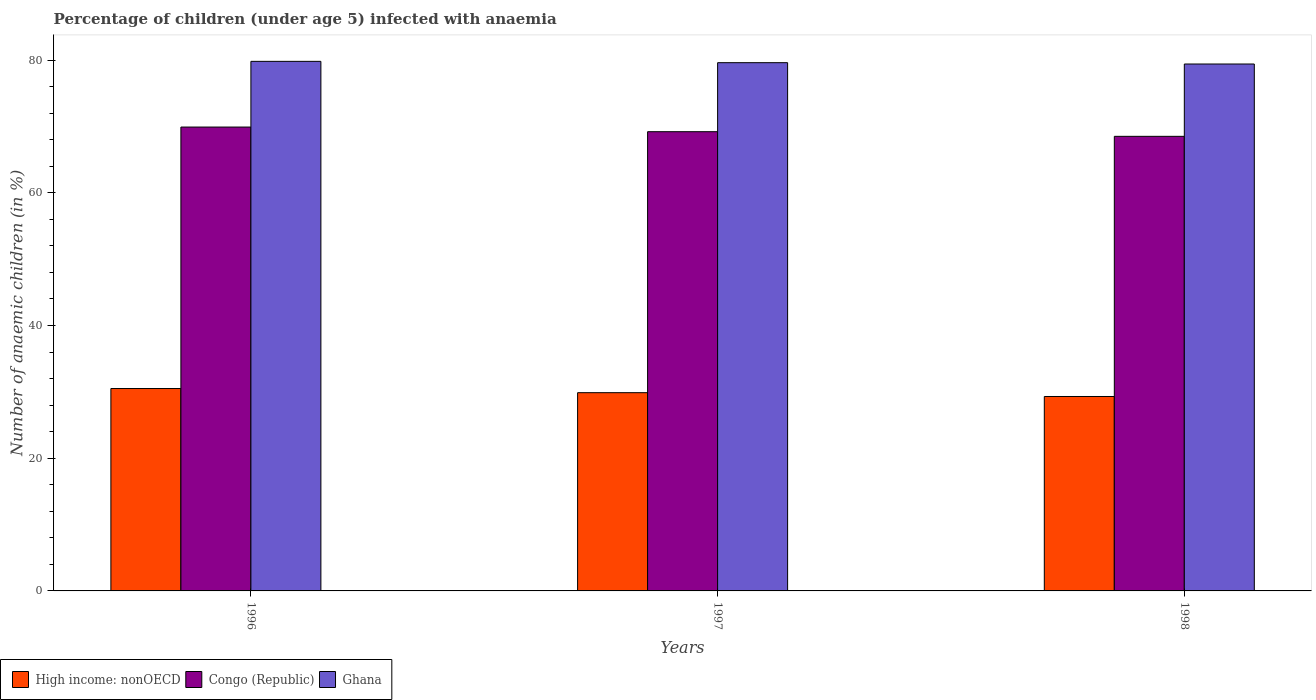How many groups of bars are there?
Offer a very short reply. 3. Are the number of bars on each tick of the X-axis equal?
Give a very brief answer. Yes. How many bars are there on the 2nd tick from the right?
Provide a short and direct response. 3. In how many cases, is the number of bars for a given year not equal to the number of legend labels?
Your response must be concise. 0. What is the percentage of children infected with anaemia in in Ghana in 1998?
Ensure brevity in your answer.  79.4. Across all years, what is the maximum percentage of children infected with anaemia in in Congo (Republic)?
Keep it short and to the point. 69.9. Across all years, what is the minimum percentage of children infected with anaemia in in High income: nonOECD?
Offer a very short reply. 29.3. In which year was the percentage of children infected with anaemia in in Congo (Republic) maximum?
Offer a very short reply. 1996. What is the total percentage of children infected with anaemia in in Ghana in the graph?
Keep it short and to the point. 238.8. What is the difference between the percentage of children infected with anaemia in in Ghana in 1996 and that in 1997?
Your answer should be compact. 0.2. What is the difference between the percentage of children infected with anaemia in in Congo (Republic) in 1997 and the percentage of children infected with anaemia in in High income: nonOECD in 1996?
Your answer should be compact. 38.7. What is the average percentage of children infected with anaemia in in High income: nonOECD per year?
Offer a very short reply. 29.89. In the year 1998, what is the difference between the percentage of children infected with anaemia in in Ghana and percentage of children infected with anaemia in in Congo (Republic)?
Give a very brief answer. 10.9. What is the ratio of the percentage of children infected with anaemia in in Ghana in 1996 to that in 1998?
Provide a succinct answer. 1.01. What is the difference between the highest and the second highest percentage of children infected with anaemia in in Ghana?
Give a very brief answer. 0.2. What is the difference between the highest and the lowest percentage of children infected with anaemia in in Ghana?
Give a very brief answer. 0.4. Is the sum of the percentage of children infected with anaemia in in Congo (Republic) in 1996 and 1998 greater than the maximum percentage of children infected with anaemia in in High income: nonOECD across all years?
Make the answer very short. Yes. What does the 3rd bar from the right in 1996 represents?
Offer a terse response. High income: nonOECD. How many bars are there?
Your answer should be very brief. 9. Are all the bars in the graph horizontal?
Your answer should be very brief. No. How many years are there in the graph?
Your answer should be very brief. 3. What is the difference between two consecutive major ticks on the Y-axis?
Provide a short and direct response. 20. Are the values on the major ticks of Y-axis written in scientific E-notation?
Offer a terse response. No. Does the graph contain grids?
Provide a succinct answer. No. Where does the legend appear in the graph?
Ensure brevity in your answer.  Bottom left. How many legend labels are there?
Your answer should be compact. 3. How are the legend labels stacked?
Your answer should be very brief. Horizontal. What is the title of the graph?
Provide a short and direct response. Percentage of children (under age 5) infected with anaemia. Does "Upper middle income" appear as one of the legend labels in the graph?
Keep it short and to the point. No. What is the label or title of the Y-axis?
Provide a succinct answer. Number of anaemic children (in %). What is the Number of anaemic children (in %) of High income: nonOECD in 1996?
Offer a very short reply. 30.5. What is the Number of anaemic children (in %) in Congo (Republic) in 1996?
Ensure brevity in your answer.  69.9. What is the Number of anaemic children (in %) of Ghana in 1996?
Offer a terse response. 79.8. What is the Number of anaemic children (in %) in High income: nonOECD in 1997?
Your answer should be compact. 29.87. What is the Number of anaemic children (in %) in Congo (Republic) in 1997?
Provide a succinct answer. 69.2. What is the Number of anaemic children (in %) in Ghana in 1997?
Provide a succinct answer. 79.6. What is the Number of anaemic children (in %) of High income: nonOECD in 1998?
Offer a terse response. 29.3. What is the Number of anaemic children (in %) in Congo (Republic) in 1998?
Make the answer very short. 68.5. What is the Number of anaemic children (in %) in Ghana in 1998?
Make the answer very short. 79.4. Across all years, what is the maximum Number of anaemic children (in %) of High income: nonOECD?
Make the answer very short. 30.5. Across all years, what is the maximum Number of anaemic children (in %) of Congo (Republic)?
Offer a very short reply. 69.9. Across all years, what is the maximum Number of anaemic children (in %) in Ghana?
Your answer should be compact. 79.8. Across all years, what is the minimum Number of anaemic children (in %) in High income: nonOECD?
Your answer should be compact. 29.3. Across all years, what is the minimum Number of anaemic children (in %) of Congo (Republic)?
Provide a short and direct response. 68.5. Across all years, what is the minimum Number of anaemic children (in %) in Ghana?
Offer a terse response. 79.4. What is the total Number of anaemic children (in %) in High income: nonOECD in the graph?
Keep it short and to the point. 89.67. What is the total Number of anaemic children (in %) in Congo (Republic) in the graph?
Offer a very short reply. 207.6. What is the total Number of anaemic children (in %) in Ghana in the graph?
Provide a succinct answer. 238.8. What is the difference between the Number of anaemic children (in %) of High income: nonOECD in 1996 and that in 1997?
Provide a short and direct response. 0.63. What is the difference between the Number of anaemic children (in %) of Congo (Republic) in 1996 and that in 1997?
Provide a short and direct response. 0.7. What is the difference between the Number of anaemic children (in %) of Ghana in 1996 and that in 1997?
Your answer should be very brief. 0.2. What is the difference between the Number of anaemic children (in %) of High income: nonOECD in 1996 and that in 1998?
Keep it short and to the point. 1.2. What is the difference between the Number of anaemic children (in %) in Congo (Republic) in 1996 and that in 1998?
Offer a very short reply. 1.4. What is the difference between the Number of anaemic children (in %) in Ghana in 1996 and that in 1998?
Offer a terse response. 0.4. What is the difference between the Number of anaemic children (in %) in High income: nonOECD in 1997 and that in 1998?
Provide a succinct answer. 0.57. What is the difference between the Number of anaemic children (in %) in Congo (Republic) in 1997 and that in 1998?
Your response must be concise. 0.7. What is the difference between the Number of anaemic children (in %) of Ghana in 1997 and that in 1998?
Provide a succinct answer. 0.2. What is the difference between the Number of anaemic children (in %) of High income: nonOECD in 1996 and the Number of anaemic children (in %) of Congo (Republic) in 1997?
Your answer should be compact. -38.7. What is the difference between the Number of anaemic children (in %) in High income: nonOECD in 1996 and the Number of anaemic children (in %) in Ghana in 1997?
Give a very brief answer. -49.1. What is the difference between the Number of anaemic children (in %) in Congo (Republic) in 1996 and the Number of anaemic children (in %) in Ghana in 1997?
Your response must be concise. -9.7. What is the difference between the Number of anaemic children (in %) in High income: nonOECD in 1996 and the Number of anaemic children (in %) in Congo (Republic) in 1998?
Offer a terse response. -38. What is the difference between the Number of anaemic children (in %) of High income: nonOECD in 1996 and the Number of anaemic children (in %) of Ghana in 1998?
Make the answer very short. -48.9. What is the difference between the Number of anaemic children (in %) in Congo (Republic) in 1996 and the Number of anaemic children (in %) in Ghana in 1998?
Your response must be concise. -9.5. What is the difference between the Number of anaemic children (in %) in High income: nonOECD in 1997 and the Number of anaemic children (in %) in Congo (Republic) in 1998?
Your answer should be very brief. -38.63. What is the difference between the Number of anaemic children (in %) of High income: nonOECD in 1997 and the Number of anaemic children (in %) of Ghana in 1998?
Provide a short and direct response. -49.53. What is the difference between the Number of anaemic children (in %) of Congo (Republic) in 1997 and the Number of anaemic children (in %) of Ghana in 1998?
Make the answer very short. -10.2. What is the average Number of anaemic children (in %) in High income: nonOECD per year?
Your answer should be very brief. 29.89. What is the average Number of anaemic children (in %) of Congo (Republic) per year?
Make the answer very short. 69.2. What is the average Number of anaemic children (in %) in Ghana per year?
Offer a very short reply. 79.6. In the year 1996, what is the difference between the Number of anaemic children (in %) in High income: nonOECD and Number of anaemic children (in %) in Congo (Republic)?
Your answer should be very brief. -39.4. In the year 1996, what is the difference between the Number of anaemic children (in %) of High income: nonOECD and Number of anaemic children (in %) of Ghana?
Give a very brief answer. -49.3. In the year 1997, what is the difference between the Number of anaemic children (in %) of High income: nonOECD and Number of anaemic children (in %) of Congo (Republic)?
Make the answer very short. -39.33. In the year 1997, what is the difference between the Number of anaemic children (in %) of High income: nonOECD and Number of anaemic children (in %) of Ghana?
Offer a very short reply. -49.73. In the year 1997, what is the difference between the Number of anaemic children (in %) of Congo (Republic) and Number of anaemic children (in %) of Ghana?
Provide a succinct answer. -10.4. In the year 1998, what is the difference between the Number of anaemic children (in %) in High income: nonOECD and Number of anaemic children (in %) in Congo (Republic)?
Ensure brevity in your answer.  -39.2. In the year 1998, what is the difference between the Number of anaemic children (in %) in High income: nonOECD and Number of anaemic children (in %) in Ghana?
Ensure brevity in your answer.  -50.1. In the year 1998, what is the difference between the Number of anaemic children (in %) in Congo (Republic) and Number of anaemic children (in %) in Ghana?
Offer a very short reply. -10.9. What is the ratio of the Number of anaemic children (in %) in High income: nonOECD in 1996 to that in 1997?
Ensure brevity in your answer.  1.02. What is the ratio of the Number of anaemic children (in %) in High income: nonOECD in 1996 to that in 1998?
Make the answer very short. 1.04. What is the ratio of the Number of anaemic children (in %) in Congo (Republic) in 1996 to that in 1998?
Ensure brevity in your answer.  1.02. What is the ratio of the Number of anaemic children (in %) of High income: nonOECD in 1997 to that in 1998?
Offer a very short reply. 1.02. What is the ratio of the Number of anaemic children (in %) in Congo (Republic) in 1997 to that in 1998?
Your response must be concise. 1.01. What is the ratio of the Number of anaemic children (in %) of Ghana in 1997 to that in 1998?
Your answer should be very brief. 1. What is the difference between the highest and the second highest Number of anaemic children (in %) of High income: nonOECD?
Provide a short and direct response. 0.63. What is the difference between the highest and the second highest Number of anaemic children (in %) in Congo (Republic)?
Your answer should be compact. 0.7. What is the difference between the highest and the lowest Number of anaemic children (in %) of High income: nonOECD?
Provide a short and direct response. 1.2. What is the difference between the highest and the lowest Number of anaemic children (in %) in Congo (Republic)?
Your response must be concise. 1.4. 